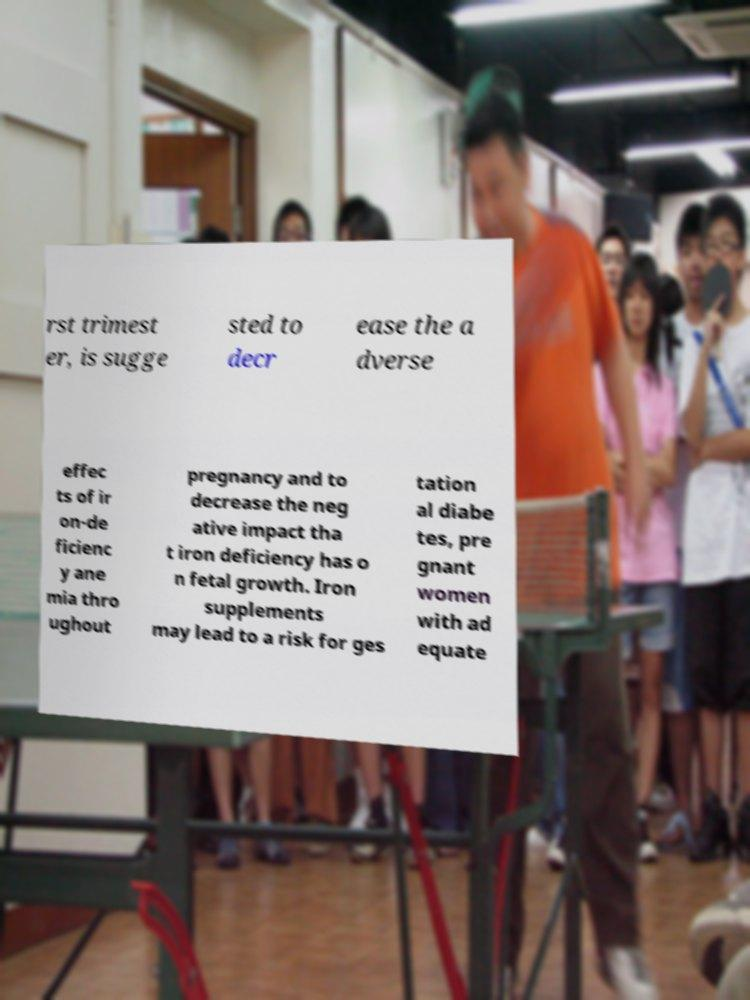There's text embedded in this image that I need extracted. Can you transcribe it verbatim? rst trimest er, is sugge sted to decr ease the a dverse effec ts of ir on-de ficienc y ane mia thro ughout pregnancy and to decrease the neg ative impact tha t iron deficiency has o n fetal growth. Iron supplements may lead to a risk for ges tation al diabe tes, pre gnant women with ad equate 